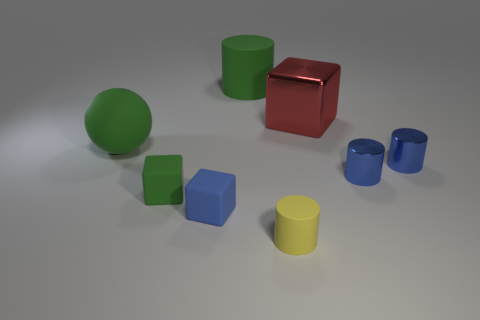Subtract all purple blocks. Subtract all brown cylinders. How many blocks are left? 3 Add 1 brown metallic spheres. How many objects exist? 9 Subtract all cubes. How many objects are left? 5 Subtract all green cubes. Subtract all metal cylinders. How many objects are left? 5 Add 5 large red objects. How many large red objects are left? 6 Add 8 tiny yellow objects. How many tiny yellow objects exist? 9 Subtract 1 green cubes. How many objects are left? 7 